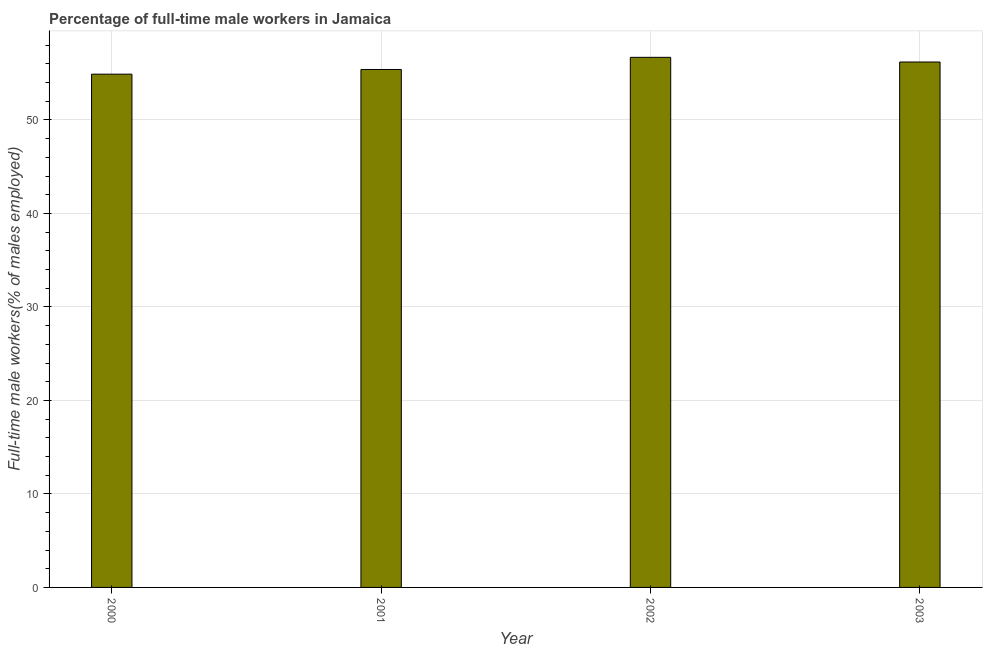What is the title of the graph?
Offer a terse response. Percentage of full-time male workers in Jamaica. What is the label or title of the Y-axis?
Offer a terse response. Full-time male workers(% of males employed). What is the percentage of full-time male workers in 2000?
Ensure brevity in your answer.  54.9. Across all years, what is the maximum percentage of full-time male workers?
Give a very brief answer. 56.7. Across all years, what is the minimum percentage of full-time male workers?
Make the answer very short. 54.9. In which year was the percentage of full-time male workers minimum?
Provide a succinct answer. 2000. What is the sum of the percentage of full-time male workers?
Make the answer very short. 223.2. What is the average percentage of full-time male workers per year?
Your response must be concise. 55.8. What is the median percentage of full-time male workers?
Make the answer very short. 55.8. In how many years, is the percentage of full-time male workers greater than 56 %?
Offer a very short reply. 2. Do a majority of the years between 2002 and 2001 (inclusive) have percentage of full-time male workers greater than 34 %?
Keep it short and to the point. No. What is the ratio of the percentage of full-time male workers in 2002 to that in 2003?
Your response must be concise. 1.01. Is the difference between the percentage of full-time male workers in 2000 and 2002 greater than the difference between any two years?
Offer a very short reply. Yes. What is the difference between the highest and the second highest percentage of full-time male workers?
Ensure brevity in your answer.  0.5. What is the difference between the highest and the lowest percentage of full-time male workers?
Keep it short and to the point. 1.8. In how many years, is the percentage of full-time male workers greater than the average percentage of full-time male workers taken over all years?
Offer a very short reply. 2. How many bars are there?
Offer a terse response. 4. How many years are there in the graph?
Offer a terse response. 4. Are the values on the major ticks of Y-axis written in scientific E-notation?
Ensure brevity in your answer.  No. What is the Full-time male workers(% of males employed) in 2000?
Provide a succinct answer. 54.9. What is the Full-time male workers(% of males employed) in 2001?
Offer a terse response. 55.4. What is the Full-time male workers(% of males employed) of 2002?
Offer a very short reply. 56.7. What is the Full-time male workers(% of males employed) of 2003?
Your answer should be very brief. 56.2. What is the difference between the Full-time male workers(% of males employed) in 2001 and 2002?
Provide a succinct answer. -1.3. What is the ratio of the Full-time male workers(% of males employed) in 2000 to that in 2001?
Keep it short and to the point. 0.99. What is the ratio of the Full-time male workers(% of males employed) in 2000 to that in 2002?
Offer a terse response. 0.97. What is the ratio of the Full-time male workers(% of males employed) in 2001 to that in 2002?
Keep it short and to the point. 0.98. 